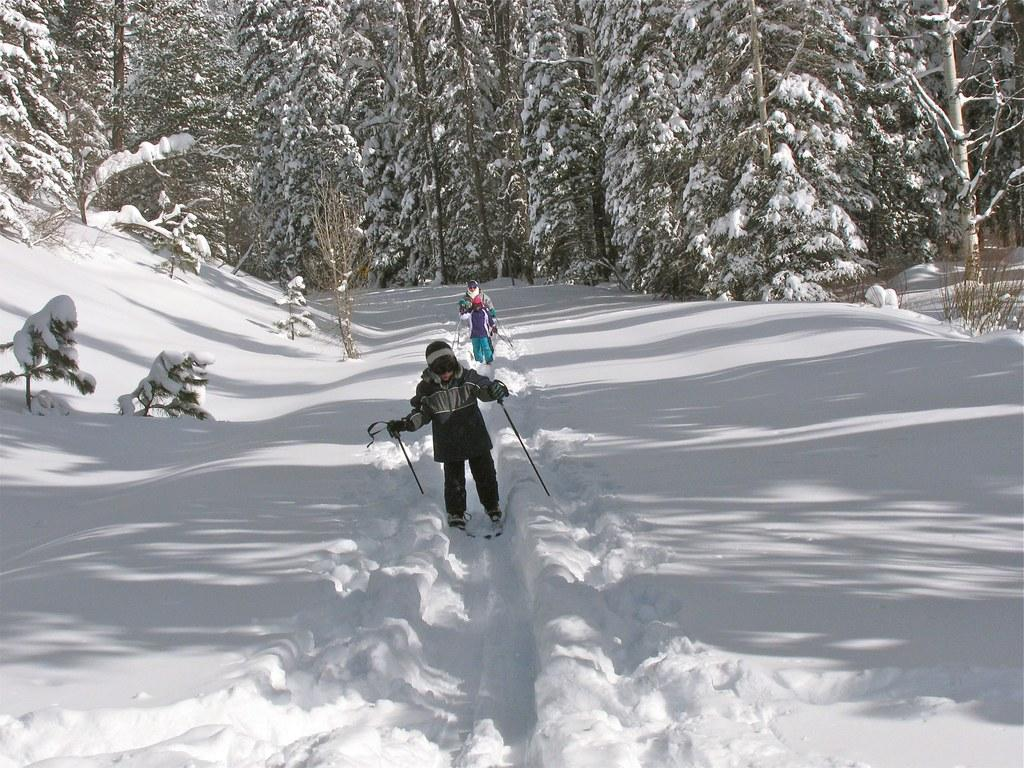How many people are in the image? There are two persons in the image. What are the persons doing in the image? The persons are skating on a snow land. What equipment are the persons using for skating? The persons are wearing skating boards. What objects are the persons holding in their hands? The persons are holding sticks in their hands. What can be seen in the background of the image? There are trees in the background of the image. What is the condition of the trees in the image? The trees are covered with snow. Can you tell me which actor is performing in the image? There is no actor present in the image; it features two persons skating on a snow land. What type of owl can be seen in the image? There is no owl present in the image. 